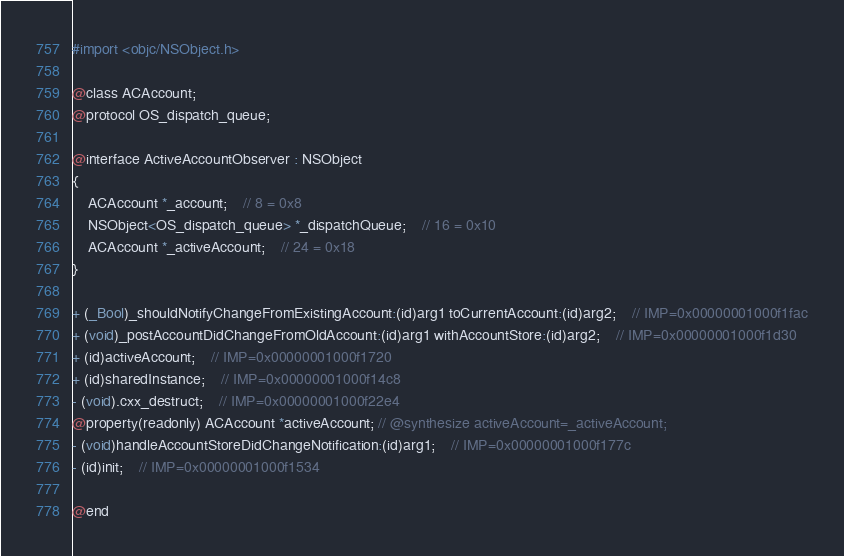<code> <loc_0><loc_0><loc_500><loc_500><_C_>#import <objc/NSObject.h>

@class ACAccount;
@protocol OS_dispatch_queue;

@interface ActiveAccountObserver : NSObject
{
    ACAccount *_account;	// 8 = 0x8
    NSObject<OS_dispatch_queue> *_dispatchQueue;	// 16 = 0x10
    ACAccount *_activeAccount;	// 24 = 0x18
}

+ (_Bool)_shouldNotifyChangeFromExistingAccount:(id)arg1 toCurrentAccount:(id)arg2;	// IMP=0x00000001000f1fac
+ (void)_postAccountDidChangeFromOldAccount:(id)arg1 withAccountStore:(id)arg2;	// IMP=0x00000001000f1d30
+ (id)activeAccount;	// IMP=0x00000001000f1720
+ (id)sharedInstance;	// IMP=0x00000001000f14c8
- (void).cxx_destruct;	// IMP=0x00000001000f22e4
@property(readonly) ACAccount *activeAccount; // @synthesize activeAccount=_activeAccount;
- (void)handleAccountStoreDidChangeNotification:(id)arg1;	// IMP=0x00000001000f177c
- (id)init;	// IMP=0x00000001000f1534

@end

</code> 